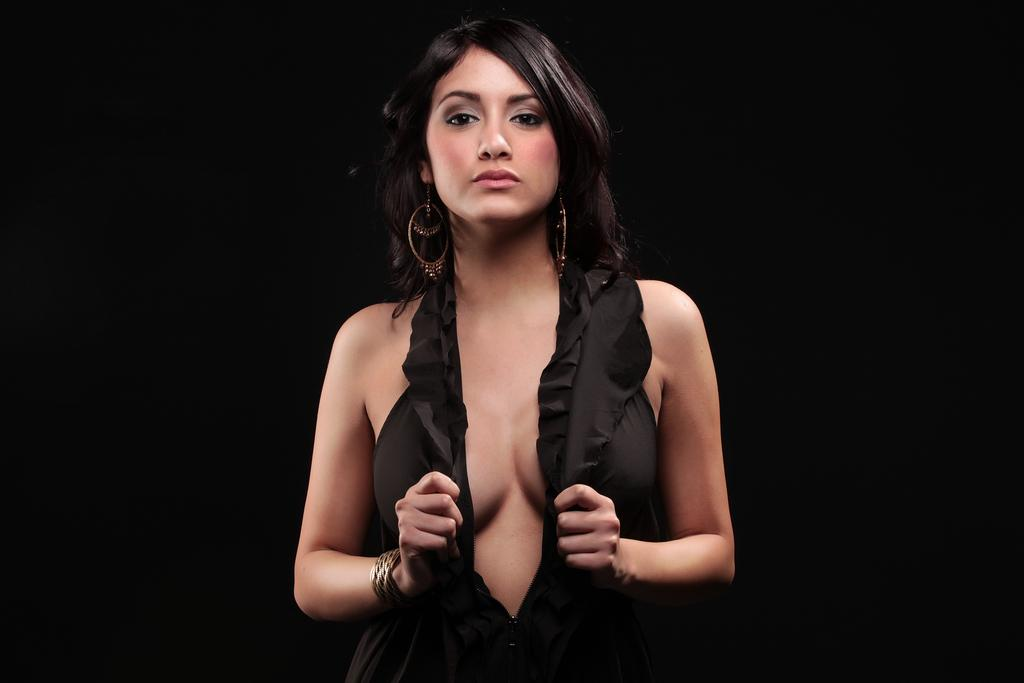Who is the main subject in the image? There is a woman in the image. What is the woman wearing? The woman is wearing a black dress. What is the woman doing in the image? The woman is posing for a photo. What is the color of the background in the image? The background of the image is in dark color. Can you see a ticket in the woman's hand in the image? There is no ticket visible in the woman's hand in the image. Is the woman sleeping in the image? No, the woman is not sleeping in the image; she is posing for a photo. 